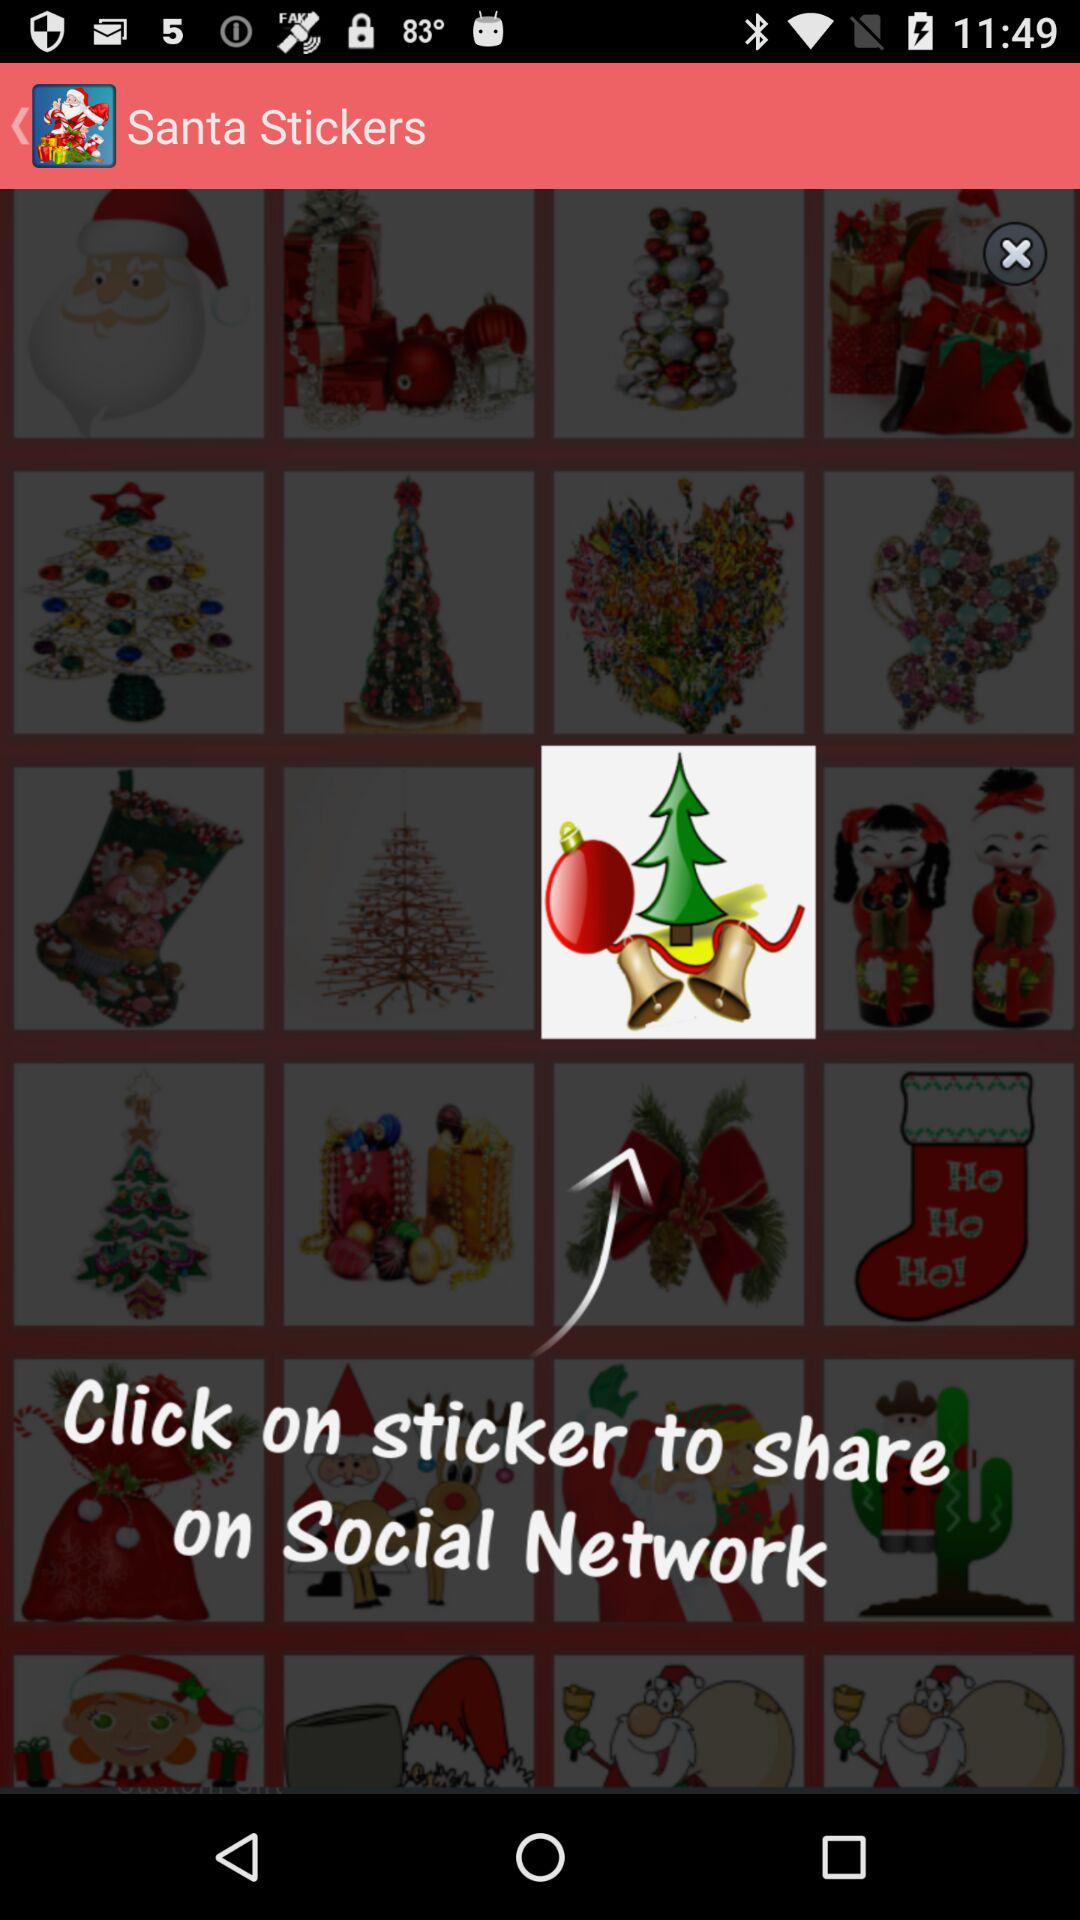What is the name of the application?
When the provided information is insufficient, respond with <no answer>. <no answer> 